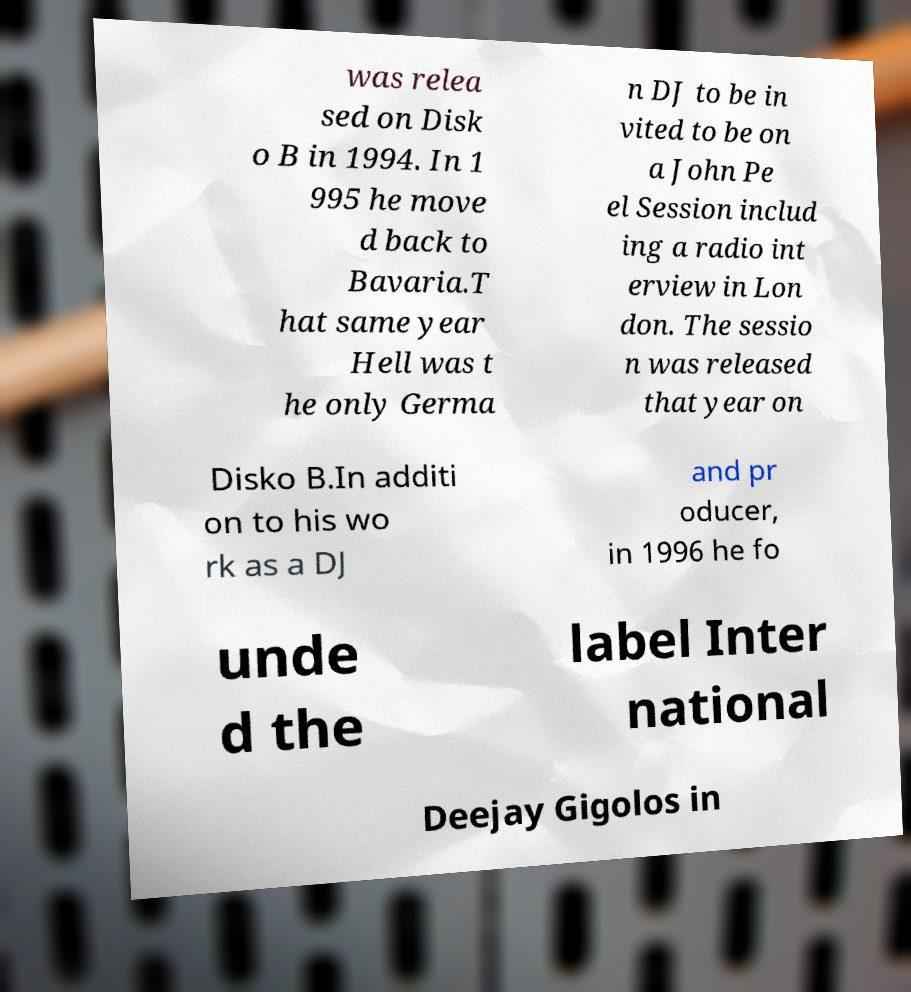Can you read and provide the text displayed in the image?This photo seems to have some interesting text. Can you extract and type it out for me? was relea sed on Disk o B in 1994. In 1 995 he move d back to Bavaria.T hat same year Hell was t he only Germa n DJ to be in vited to be on a John Pe el Session includ ing a radio int erview in Lon don. The sessio n was released that year on Disko B.In additi on to his wo rk as a DJ and pr oducer, in 1996 he fo unde d the label Inter national Deejay Gigolos in 